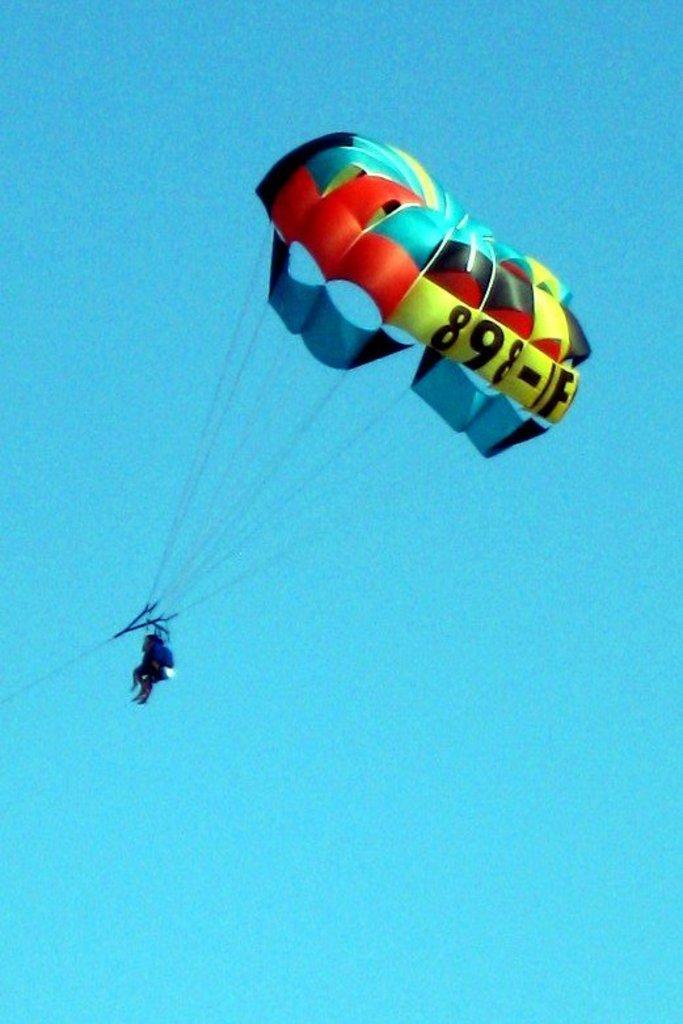Can you describe this image briefly? In the image there is a person flying in the air with parachute. 